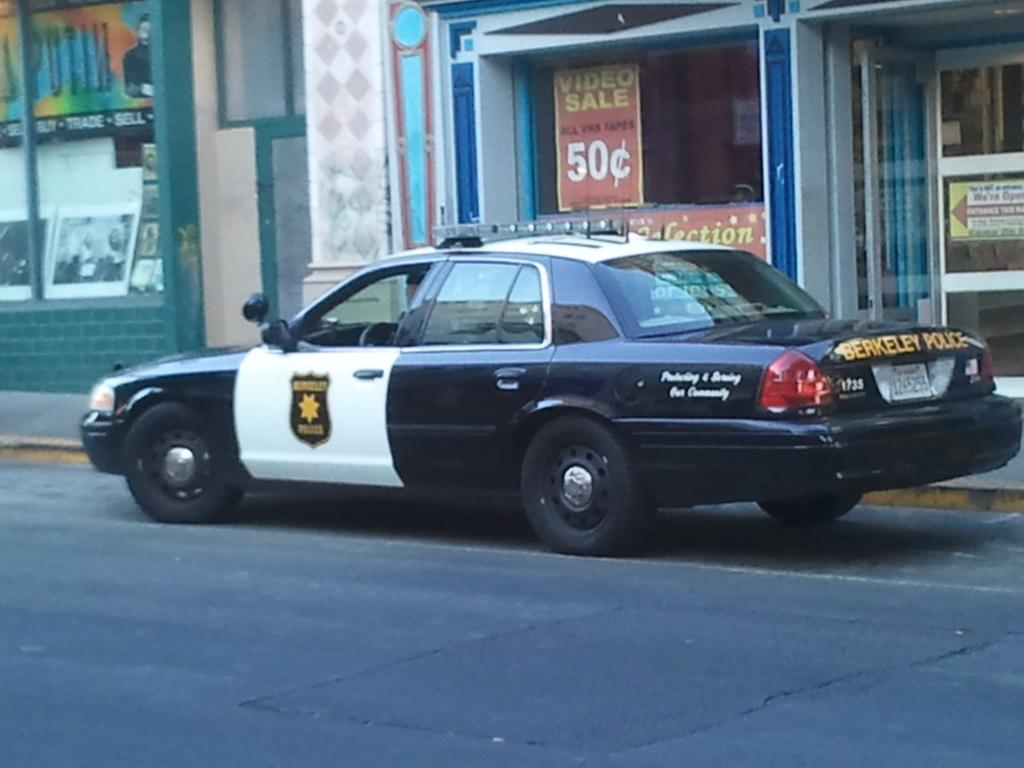Provide a one-sentence caption for the provided image. A Berkeley police cruiser is parked by the curb in front of a store. 